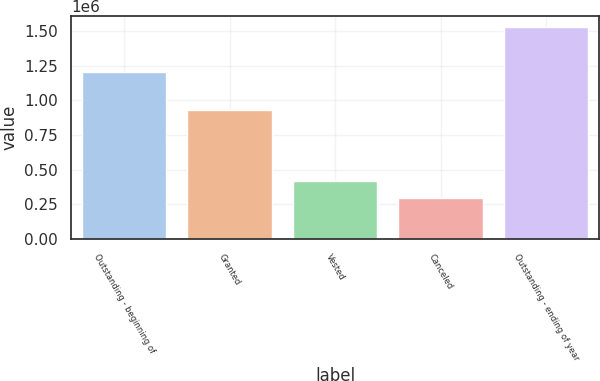<chart> <loc_0><loc_0><loc_500><loc_500><bar_chart><fcel>Outstanding - beginning of<fcel>Granted<fcel>Vested<fcel>Canceled<fcel>Outstanding - ending of year<nl><fcel>1.20385e+06<fcel>932392<fcel>420576<fcel>297283<fcel>1.53021e+06<nl></chart> 